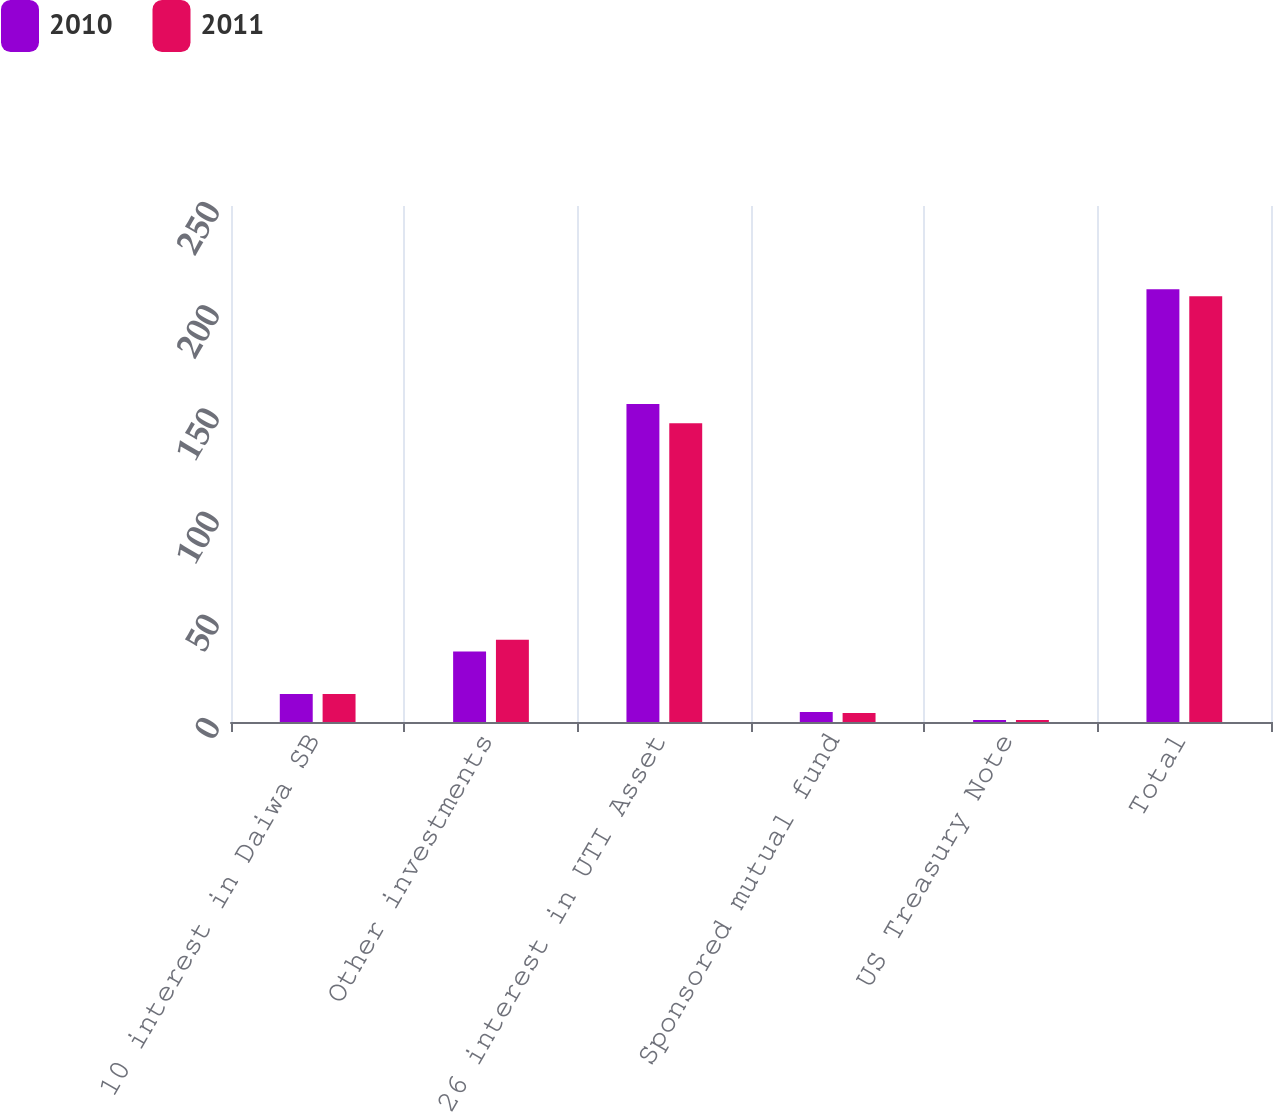Convert chart to OTSL. <chart><loc_0><loc_0><loc_500><loc_500><stacked_bar_chart><ecel><fcel>10 interest in Daiwa SB<fcel>Other investments<fcel>26 interest in UTI Asset<fcel>Sponsored mutual fund<fcel>US Treasury Note<fcel>Total<nl><fcel>2010<fcel>13.6<fcel>34.2<fcel>154.1<fcel>4.8<fcel>1<fcel>209.7<nl><fcel>2011<fcel>13.6<fcel>39.9<fcel>144.8<fcel>4.4<fcel>1<fcel>206.3<nl></chart> 